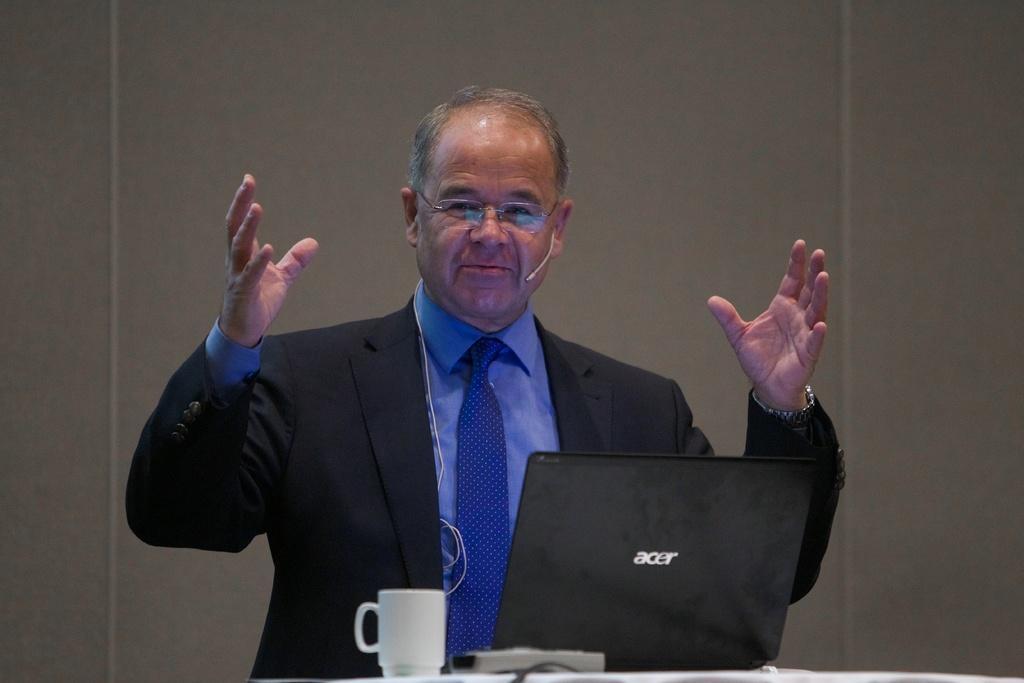How would you summarize this image in a sentence or two? Middle of the image we can see a person, laptop, remote and coffee cup. Background of the image there is a wall. 